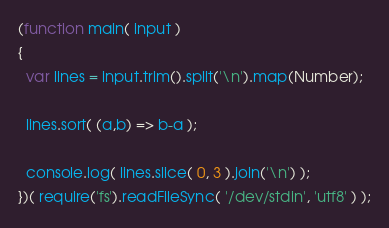<code> <loc_0><loc_0><loc_500><loc_500><_JavaScript_>(function main( input )
{
  var lines = input.trim().split('\n').map(Number);
  
  lines.sort( (a,b) => b-a );

  console.log( lines.slice( 0, 3 ).join('\n') );
})( require('fs').readFileSync( '/dev/stdin', 'utf8' ) );</code> 